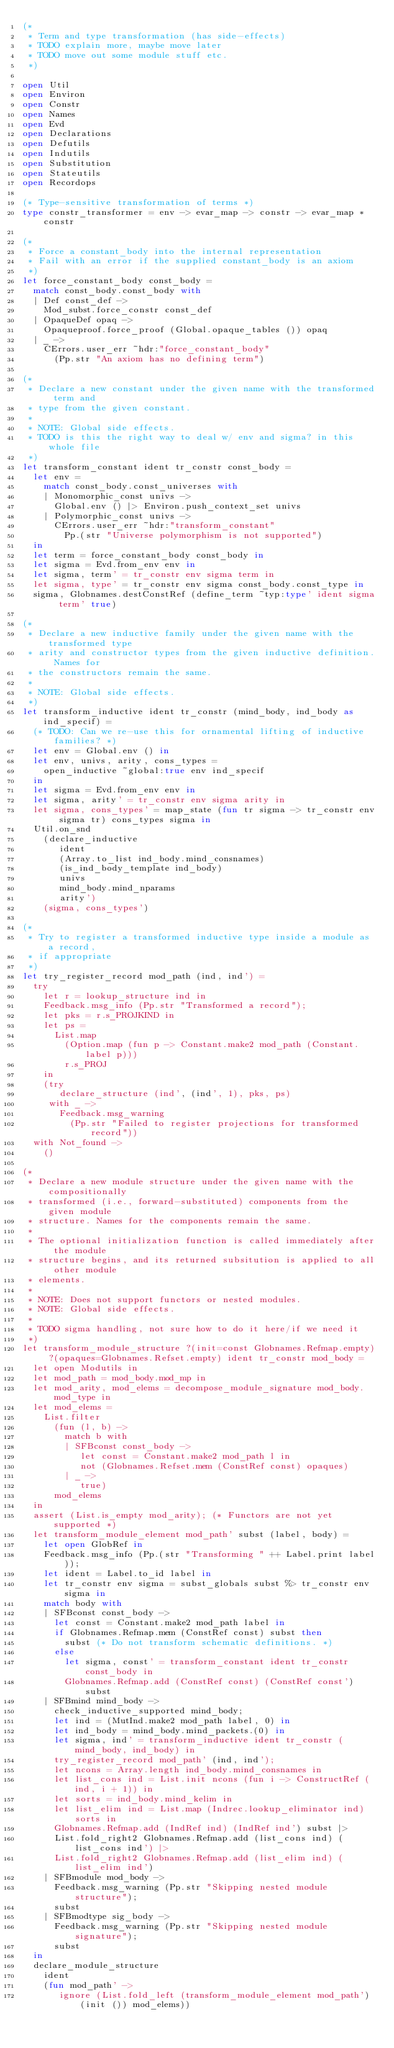Convert code to text. <code><loc_0><loc_0><loc_500><loc_500><_OCaml_>(*
 * Term and type transformation (has side-effects)
 * TODO explain more, maybe move later
 * TODO move out some module stuff etc.
 *)

open Util
open Environ
open Constr
open Names
open Evd
open Declarations
open Defutils
open Indutils
open Substitution
open Stateutils
open Recordops

(* Type-sensitive transformation of terms *)
type constr_transformer = env -> evar_map -> constr -> evar_map * constr

(*
 * Force a constant_body into the internal representation
 * Fail with an error if the supplied constant_body is an axiom
 *)
let force_constant_body const_body =
  match const_body.const_body with
  | Def const_def ->
    Mod_subst.force_constr const_def
  | OpaqueDef opaq ->
    Opaqueproof.force_proof (Global.opaque_tables ()) opaq
  | _ ->
    CErrors.user_err ~hdr:"force_constant_body"
      (Pp.str "An axiom has no defining term")

(*
 * Declare a new constant under the given name with the transformed term and
 * type from the given constant.
 *
 * NOTE: Global side effects.
 * TODO is this the right way to deal w/ env and sigma? in this whole file
 *)
let transform_constant ident tr_constr const_body =
  let env =
    match const_body.const_universes with
    | Monomorphic_const univs ->
      Global.env () |> Environ.push_context_set univs
    | Polymorphic_const univs ->
      CErrors.user_err ~hdr:"transform_constant"
        Pp.(str "Universe polymorphism is not supported")
  in
  let term = force_constant_body const_body in
  let sigma = Evd.from_env env in
  let sigma, term' = tr_constr env sigma term in
  let sigma, type' = tr_constr env sigma const_body.const_type in
  sigma, Globnames.destConstRef (define_term ~typ:type' ident sigma term' true)

(*
 * Declare a new inductive family under the given name with the transformed type
 * arity and constructor types from the given inductive definition. Names for
 * the constructors remain the same.
 *
 * NOTE: Global side effects.
 *)
let transform_inductive ident tr_constr (mind_body, ind_body as ind_specif) =
  (* TODO: Can we re-use this for ornamental lifting of inductive families? *)
  let env = Global.env () in
  let env, univs, arity, cons_types =
    open_inductive ~global:true env ind_specif
  in
  let sigma = Evd.from_env env in
  let sigma, arity' = tr_constr env sigma arity in
  let sigma, cons_types' = map_state (fun tr sigma -> tr_constr env sigma tr) cons_types sigma in
  Util.on_snd
    (declare_inductive
       ident
       (Array.to_list ind_body.mind_consnames)
       (is_ind_body_template ind_body)
       univs
       mind_body.mind_nparams
       arity')
    (sigma, cons_types')

(*
 * Try to register a transformed inductive type inside a module as a record,
 * if appropriate
 *)
let try_register_record mod_path (ind, ind') =
  try
    let r = lookup_structure ind in
    Feedback.msg_info (Pp.str "Transformed a record");
    let pks = r.s_PROJKIND in
    let ps =
      List.map
        (Option.map (fun p -> Constant.make2 mod_path (Constant.label p)))
        r.s_PROJ
    in
    (try
       declare_structure (ind', (ind', 1), pks, ps)
     with _ ->
       Feedback.msg_warning
         (Pp.str "Failed to register projections for transformed record"))
  with Not_found ->
    ()

(*
 * Declare a new module structure under the given name with the compositionally
 * transformed (i.e., forward-substituted) components from the given module
 * structure. Names for the components remain the same.
 *
 * The optional initialization function is called immediately after the module
 * structure begins, and its returned subsitution is applied to all other module
 * elements.
 *
 * NOTE: Does not support functors or nested modules.
 * NOTE: Global side effects.
 *
 * TODO sigma handling, not sure how to do it here/if we need it
 *)
let transform_module_structure ?(init=const Globnames.Refmap.empty) ?(opaques=Globnames.Refset.empty) ident tr_constr mod_body =
  let open Modutils in
  let mod_path = mod_body.mod_mp in
  let mod_arity, mod_elems = decompose_module_signature mod_body.mod_type in
  let mod_elems =
    List.filter
      (fun (l, b) ->
        match b with
        | SFBconst const_body ->
           let const = Constant.make2 mod_path l in
           not (Globnames.Refset.mem (ConstRef const) opaques)
        | _ ->
           true)
      mod_elems
  in
  assert (List.is_empty mod_arity); (* Functors are not yet supported *)
  let transform_module_element mod_path' subst (label, body) =
    let open GlobRef in
    Feedback.msg_info (Pp.(str "Transforming " ++ Label.print label));
    let ident = Label.to_id label in
    let tr_constr env sigma = subst_globals subst %> tr_constr env sigma in
    match body with
    | SFBconst const_body ->
      let const = Constant.make2 mod_path label in
      if Globnames.Refmap.mem (ConstRef const) subst then
        subst (* Do not transform schematic definitions. *)
      else
        let sigma, const' = transform_constant ident tr_constr const_body in
        Globnames.Refmap.add (ConstRef const) (ConstRef const') subst
    | SFBmind mind_body ->
      check_inductive_supported mind_body;
      let ind = (MutInd.make2 mod_path label, 0) in
      let ind_body = mind_body.mind_packets.(0) in
      let sigma, ind' = transform_inductive ident tr_constr (mind_body, ind_body) in
      try_register_record mod_path' (ind, ind');
      let ncons = Array.length ind_body.mind_consnames in
      let list_cons ind = List.init ncons (fun i -> ConstructRef (ind, i + 1)) in
      let sorts = ind_body.mind_kelim in
      let list_elim ind = List.map (Indrec.lookup_eliminator ind) sorts in
      Globnames.Refmap.add (IndRef ind) (IndRef ind') subst |>
      List.fold_right2 Globnames.Refmap.add (list_cons ind) (list_cons ind') |>
      List.fold_right2 Globnames.Refmap.add (list_elim ind) (list_elim ind')
    | SFBmodule mod_body ->
      Feedback.msg_warning (Pp.str "Skipping nested module structure");
      subst
    | SFBmodtype sig_body ->
      Feedback.msg_warning (Pp.str "Skipping nested module signature");
      subst
  in
  declare_module_structure
    ident
    (fun mod_path' ->
       ignore (List.fold_left (transform_module_element mod_path') (init ()) mod_elems))
</code> 